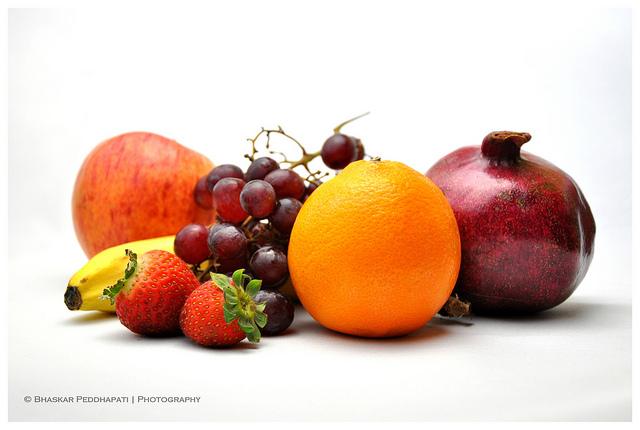How many different foods are there?
Short answer required. 6. Is the light source in the photo directly above the objects or placed low and to the right?
Quick response, please. Above. Did someone already help themselves to some of the grapes?
Write a very short answer. Yes. 